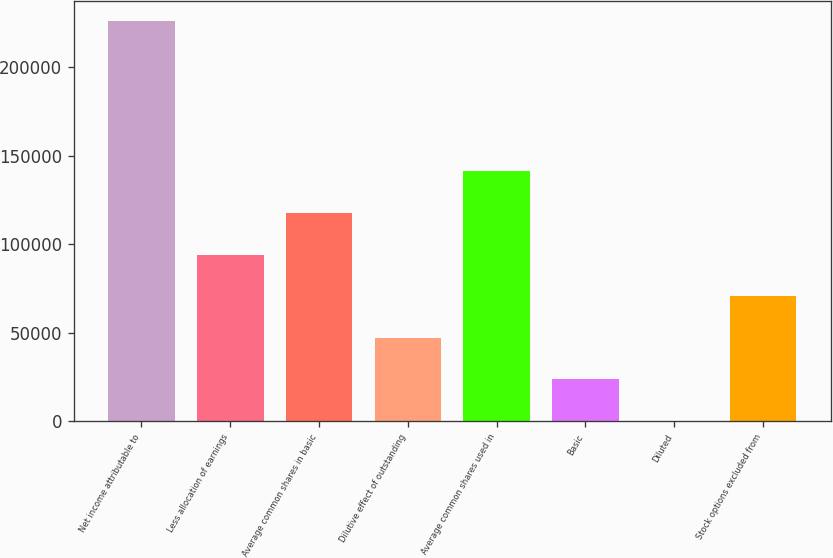<chart> <loc_0><loc_0><loc_500><loc_500><bar_chart><fcel>Net income attributable to<fcel>Less allocation of earnings<fcel>Average common shares in basic<fcel>Dilutive effect of outstanding<fcel>Average common shares used in<fcel>Basic<fcel>Diluted<fcel>Stock options excluded from<nl><fcel>226210<fcel>94032.4<fcel>117540<fcel>47017.2<fcel>141048<fcel>23509.5<fcel>1.93<fcel>70524.8<nl></chart> 